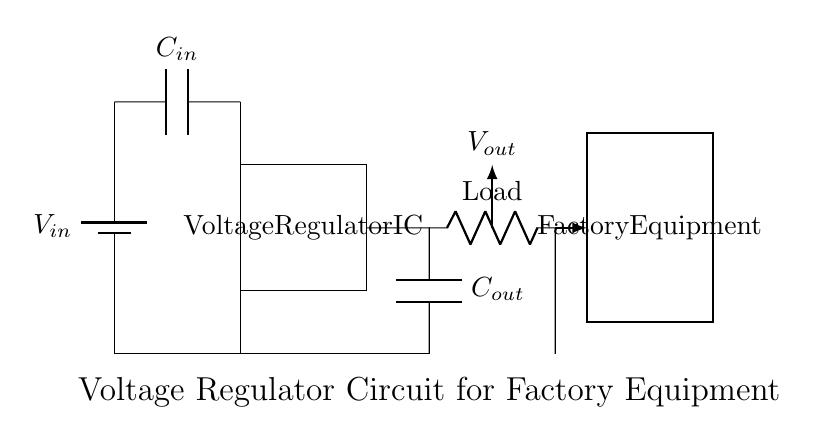What is the type of voltage source used in this circuit? The circuit diagram shows a battery symbol, indicating that the circuit uses a battery as the voltage source.
Answer: Battery What is the function of C_in in this circuit? C_in is an input capacitor placed at the input voltage to help filter noise and stabilize the input voltage for the voltage regulator.
Answer: Filtering What is the role of the voltage regulator IC? The voltage regulator IC is responsible for maintaining a stable output voltage regardless of variations in input voltage or load conditions.
Answer: Regulation What component is connected to the output of the voltage regulator? The output of the voltage regulator is connected to a capacitor labeled C_out, which further stabilizes the output voltage to the load.
Answer: Capacitor How many components are there in total in this circuit diagram? Counting the components, we have one battery, one voltage regulator IC, two capacitors (C_in and C_out), one resistor (load), and the connections make a total of five components.
Answer: Five What does V_out represent in the circuit? V_out represents the output voltage supplied to the factory equipment from the voltage regulator, ensuring the equipment receives a stable power supply.
Answer: Output voltage What type of load is depicted in this circuit? The load in this circuit is represented by a resistor symbol, indicating that the factory equipment is drawing power and has some resistance.
Answer: Resistor 